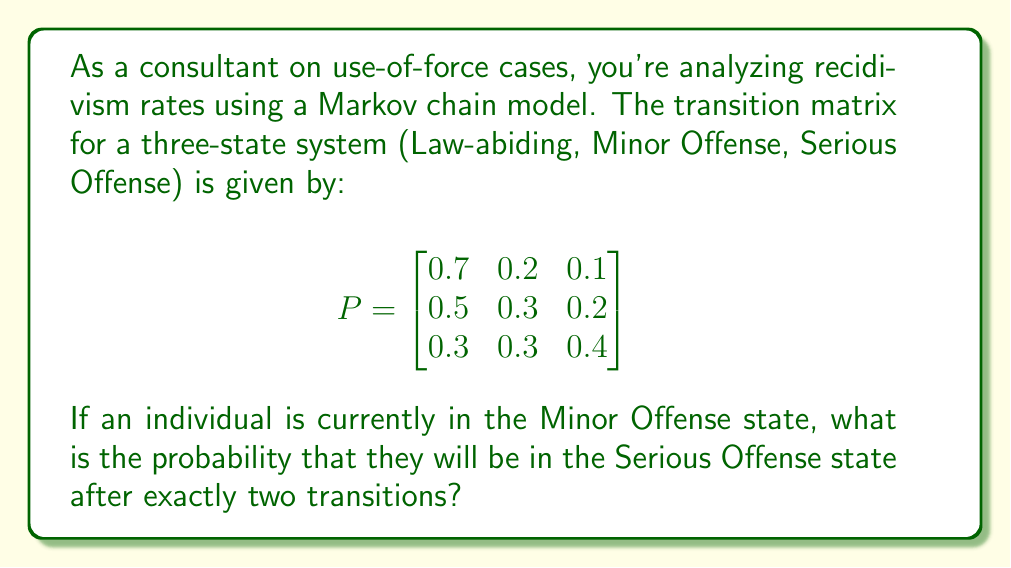Give your solution to this math problem. To solve this problem, we need to use the properties of Markov chains and matrix multiplication. Let's break it down step by step:

1) The initial state vector for an individual in the Minor Offense state is:

   $$v_0 = \begin{bmatrix} 0 \\ 1 \\ 0 \end{bmatrix}$$

2) To find the state after two transitions, we need to multiply the transition matrix by itself and then by the initial state vector:

   $$v_2 = P^2 \cdot v_0$$

3) Let's first calculate $P^2$:

   $$P^2 = P \cdot P = \begin{bmatrix}
   0.7 & 0.2 & 0.1 \\
   0.5 & 0.3 & 0.2 \\
   0.3 & 0.3 & 0.4
   \end{bmatrix} \cdot 
   \begin{bmatrix}
   0.7 & 0.2 & 0.1 \\
   0.5 & 0.3 & 0.2 \\
   0.3 & 0.3 & 0.4
   \end{bmatrix}$$

4) Performing the matrix multiplication:

   $$P^2 = \begin{bmatrix}
   0.62 & 0.22 & 0.16 \\
   0.53 & 0.27 & 0.20 \\
   0.45 & 0.30 & 0.25
   \end{bmatrix}$$

5) Now, we multiply $P^2$ by the initial state vector:

   $$v_2 = P^2 \cdot v_0 = \begin{bmatrix}
   0.62 & 0.22 & 0.16 \\
   0.53 & 0.27 & 0.20 \\
   0.45 & 0.30 & 0.25
   \end{bmatrix} \cdot 
   \begin{bmatrix}
   0 \\ 1 \\ 0
   \end{bmatrix}$$

6) This gives us:

   $$v_2 = \begin{bmatrix}
   0.22 \\ 0.27 \\ 0.30
   \end{bmatrix}$$

7) The probability of being in the Serious Offense state after two transitions is the third element of this vector.
Answer: The probability that an individual currently in the Minor Offense state will be in the Serious Offense state after exactly two transitions is 0.30 or 30%. 